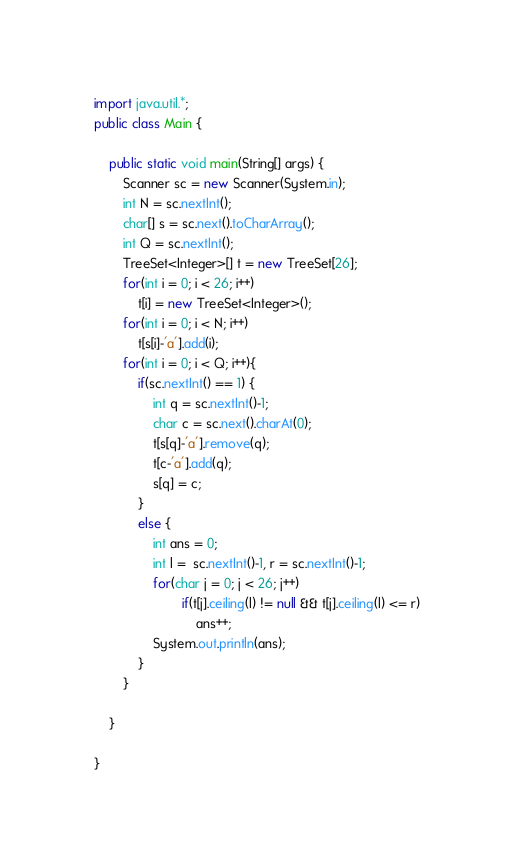Convert code to text. <code><loc_0><loc_0><loc_500><loc_500><_Java_>import java.util.*;
public class Main {

	public static void main(String[] args) {
		Scanner sc = new Scanner(System.in);
		int N = sc.nextInt();
		char[] s = sc.next().toCharArray();
		int Q = sc.nextInt();
		TreeSet<Integer>[] t = new TreeSet[26];
		for(int i = 0; i < 26; i++)
			t[i] = new TreeSet<Integer>();
		for(int i = 0; i < N; i++)
			t[s[i]-'a'].add(i);
		for(int i = 0; i < Q; i++){
			if(sc.nextInt() == 1) {
				int q = sc.nextInt()-1;
				char c = sc.next().charAt(0);
				t[s[q]-'a'].remove(q);
				t[c-'a'].add(q);
				s[q] = c;
			}
			else {
				int ans = 0;			
				int l =  sc.nextInt()-1, r = sc.nextInt()-1;
				for(char j = 0; j < 26; j++)
						if(t[j].ceiling(l) != null && t[j].ceiling(l) <= r)
							ans++;
				System.out.println(ans);
			}
		}

	}

}</code> 